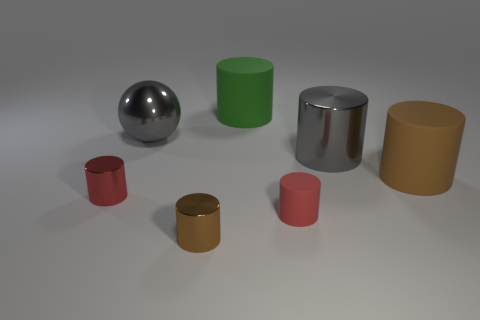There is a large gray metal thing behind the metallic cylinder behind the brown rubber cylinder; how many big green matte objects are left of it?
Your answer should be compact. 0. Do the green object and the big gray metal object left of the large green cylinder have the same shape?
Offer a very short reply. No. Is the number of small blue metal cylinders greater than the number of big green matte objects?
Make the answer very short. No. Does the brown thing that is right of the large green matte cylinder have the same shape as the red matte thing?
Your response must be concise. Yes. Is the number of green cylinders that are left of the brown rubber cylinder greater than the number of gray matte spheres?
Ensure brevity in your answer.  Yes. What color is the cylinder that is behind the gray metal thing that is left of the small red matte cylinder?
Give a very brief answer. Green. What number of gray cylinders are there?
Make the answer very short. 1. How many cylinders are both in front of the gray cylinder and on the left side of the large brown object?
Ensure brevity in your answer.  3. There is a big metallic cylinder; is it the same color as the large shiny object left of the big green matte thing?
Keep it short and to the point. Yes. The large gray metallic thing that is on the right side of the big green rubber thing has what shape?
Make the answer very short. Cylinder. 